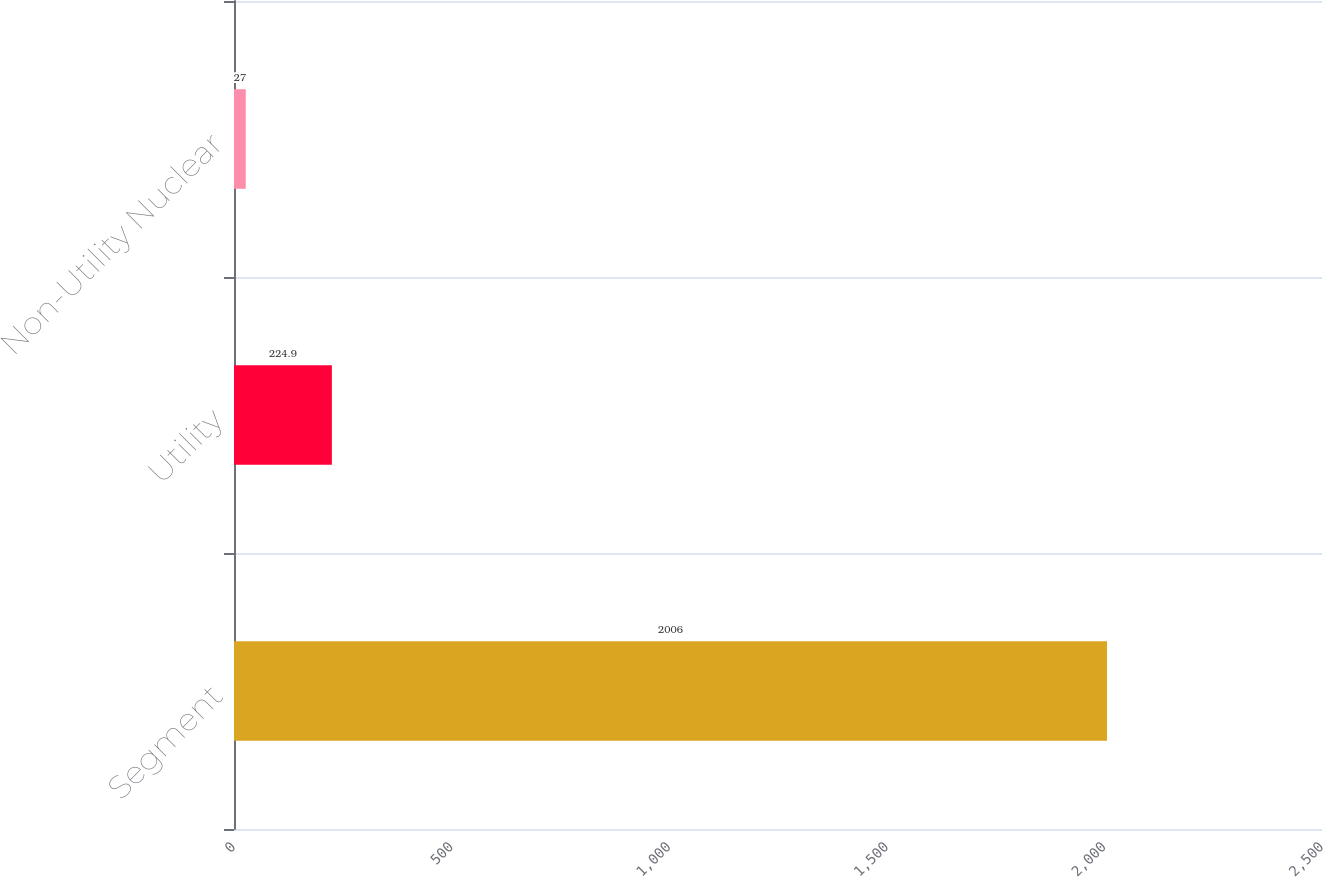Convert chart to OTSL. <chart><loc_0><loc_0><loc_500><loc_500><bar_chart><fcel>Segment<fcel>Utility<fcel>Non-Utility Nuclear<nl><fcel>2006<fcel>224.9<fcel>27<nl></chart> 